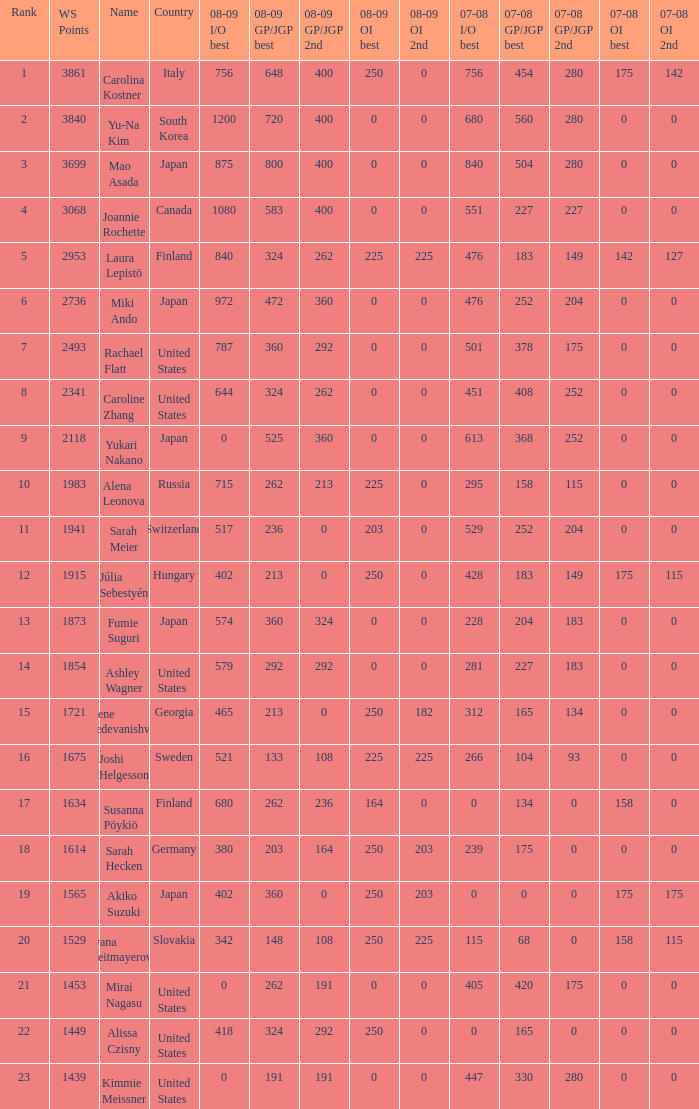I'm looking to parse the entire table for insights. Could you assist me with that? {'header': ['Rank', 'WS Points', 'Name', 'Country', '08-09 I/O best', '08-09 GP/JGP best', '08-09 GP/JGP 2nd', '08-09 OI best', '08-09 OI 2nd', '07-08 I/O best', '07-08 GP/JGP best', '07-08 GP/JGP 2nd', '07-08 OI best', '07-08 OI 2nd'], 'rows': [['1', '3861', 'Carolina Kostner', 'Italy', '756', '648', '400', '250', '0', '756', '454', '280', '175', '142'], ['2', '3840', 'Yu-Na Kim', 'South Korea', '1200', '720', '400', '0', '0', '680', '560', '280', '0', '0'], ['3', '3699', 'Mao Asada', 'Japan', '875', '800', '400', '0', '0', '840', '504', '280', '0', '0'], ['4', '3068', 'Joannie Rochette', 'Canada', '1080', '583', '400', '0', '0', '551', '227', '227', '0', '0'], ['5', '2953', 'Laura Lepistö', 'Finland', '840', '324', '262', '225', '225', '476', '183', '149', '142', '127'], ['6', '2736', 'Miki Ando', 'Japan', '972', '472', '360', '0', '0', '476', '252', '204', '0', '0'], ['7', '2493', 'Rachael Flatt', 'United States', '787', '360', '292', '0', '0', '501', '378', '175', '0', '0'], ['8', '2341', 'Caroline Zhang', 'United States', '644', '324', '262', '0', '0', '451', '408', '252', '0', '0'], ['9', '2118', 'Yukari Nakano', 'Japan', '0', '525', '360', '0', '0', '613', '368', '252', '0', '0'], ['10', '1983', 'Alena Leonova', 'Russia', '715', '262', '213', '225', '0', '295', '158', '115', '0', '0'], ['11', '1941', 'Sarah Meier', 'Switzerland', '517', '236', '0', '203', '0', '529', '252', '204', '0', '0'], ['12', '1915', 'Júlia Sebestyén', 'Hungary', '402', '213', '0', '250', '0', '428', '183', '149', '175', '115'], ['13', '1873', 'Fumie Suguri', 'Japan', '574', '360', '324', '0', '0', '228', '204', '183', '0', '0'], ['14', '1854', 'Ashley Wagner', 'United States', '579', '292', '292', '0', '0', '281', '227', '183', '0', '0'], ['15', '1721', 'Elene Gedevanishvili', 'Georgia', '465', '213', '0', '250', '182', '312', '165', '134', '0', '0'], ['16', '1675', 'Joshi Helgesson', 'Sweden', '521', '133', '108', '225', '225', '266', '104', '93', '0', '0'], ['17', '1634', 'Susanna Pöykiö', 'Finland', '680', '262', '236', '164', '0', '0', '134', '0', '158', '0'], ['18', '1614', 'Sarah Hecken', 'Germany', '380', '203', '164', '250', '203', '239', '175', '0', '0', '0'], ['19', '1565', 'Akiko Suzuki', 'Japan', '402', '360', '0', '250', '203', '0', '0', '0', '175', '175'], ['20', '1529', 'Ivana Reitmayerova', 'Slovakia', '342', '148', '108', '250', '225', '115', '68', '0', '158', '115'], ['21', '1453', 'Mirai Nagasu', 'United States', '0', '262', '191', '0', '0', '405', '420', '175', '0', '0'], ['22', '1449', 'Alissa Czisny', 'United States', '418', '324', '292', '250', '0', '0', '165', '0', '0', '0'], ['23', '1439', 'Kimmie Meissner', 'United States', '0', '191', '191', '0', '0', '447', '330', '280', '0', '0']]} What is the total 07-08 gp/jgp 2nd with the name mao asada 280.0. 